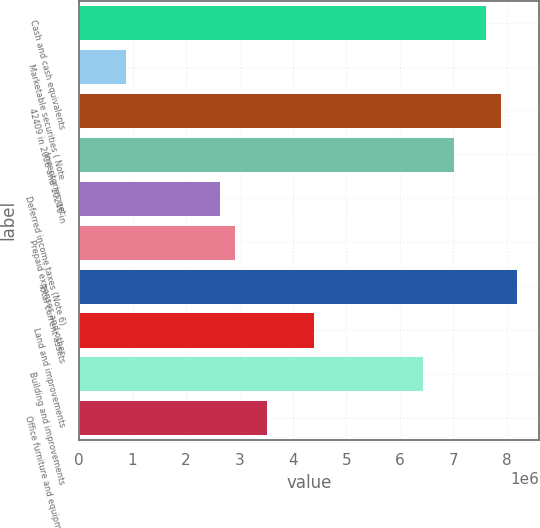<chart> <loc_0><loc_0><loc_500><loc_500><bar_chart><fcel>Cash and cash equivalents<fcel>Marketable securities ( Note<fcel>42409 in 2008 and 10246 in<fcel>Inventories net<fcel>Deferred income taxes (Note 6)<fcel>Prepaid expenses and other<fcel>Total current assets<fcel>Land and improvements<fcel>Building and improvements<fcel>Office furniture and equipment<nl><fcel>7.60231e+06<fcel>878076<fcel>7.89467e+06<fcel>7.01759e+06<fcel>2.63222e+06<fcel>2.92458e+06<fcel>8.18702e+06<fcel>4.38637e+06<fcel>6.43288e+06<fcel>3.5093e+06<nl></chart> 